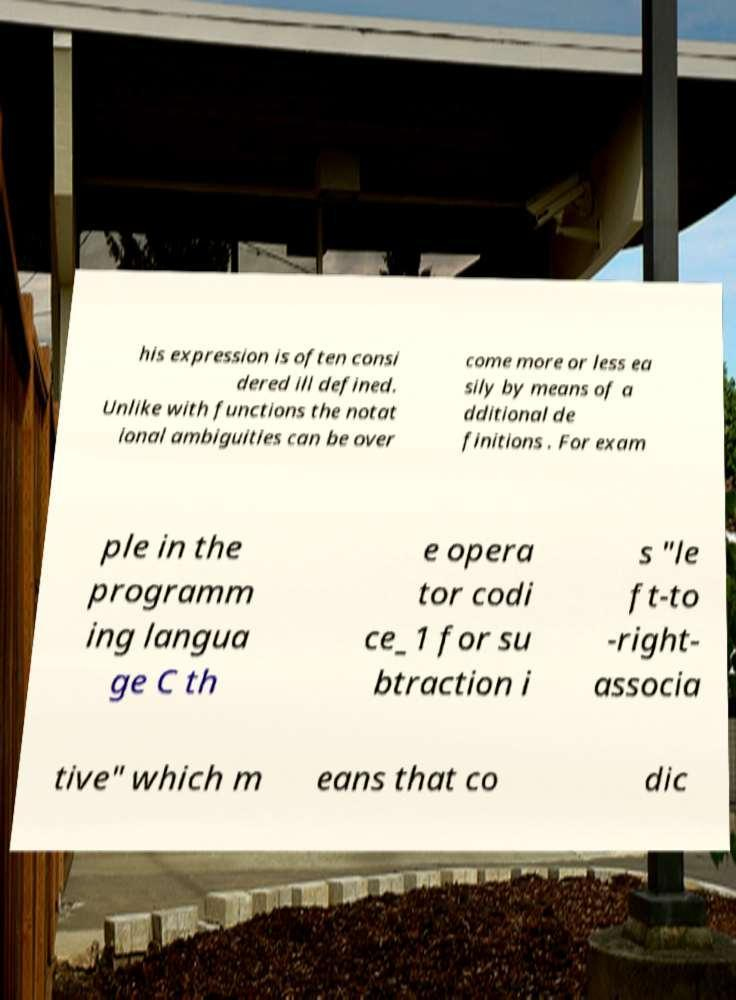There's text embedded in this image that I need extracted. Can you transcribe it verbatim? his expression is often consi dered ill defined. Unlike with functions the notat ional ambiguities can be over come more or less ea sily by means of a dditional de finitions . For exam ple in the programm ing langua ge C th e opera tor codi ce_1 for su btraction i s "le ft-to -right- associa tive" which m eans that co dic 